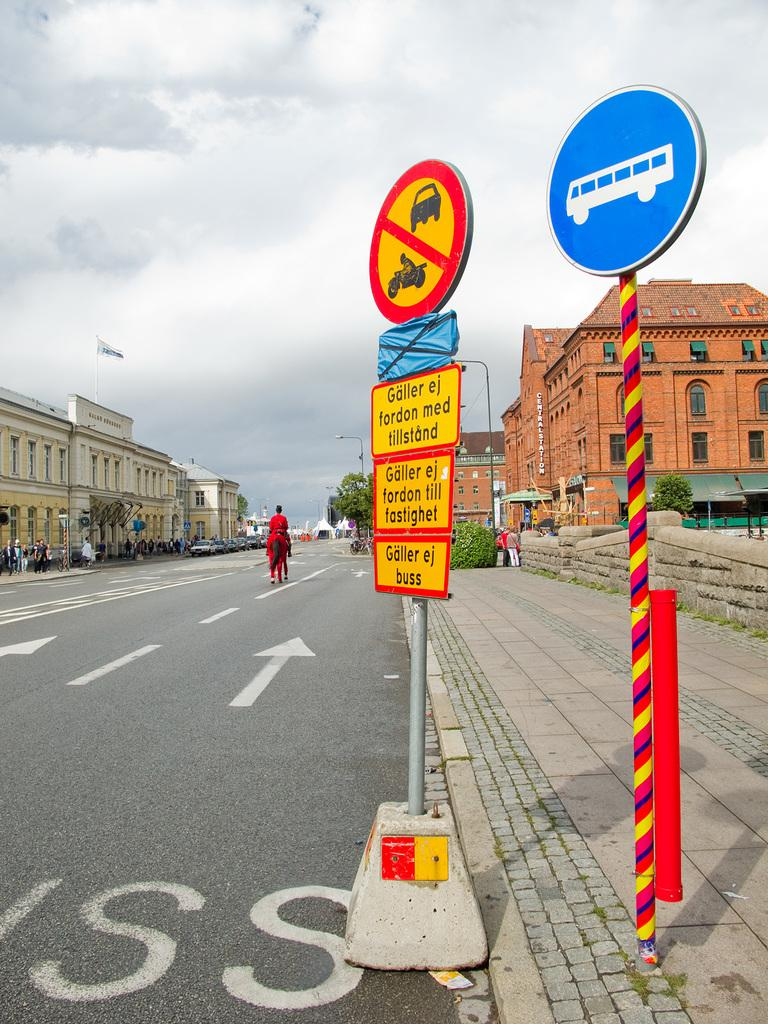<image>
Present a compact description of the photo's key features. A pole with multiple signs says "Galler ej buss" at the bottom. 